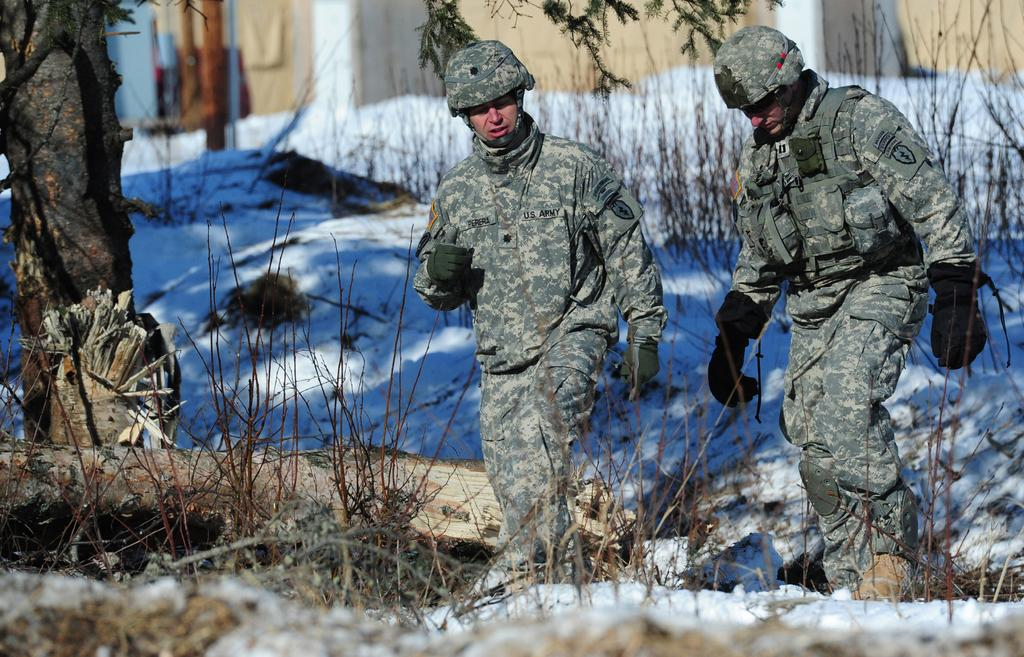How many people are wearing uniforms in the image? There are two people wearing uniforms in the image. What is located at the bottom of the image? There are plants at the bottom of the image. What can be seen in the background of the image? There is a tree and snow visible in the background of the image. What object is present in the image? There is a log in the image. What type of dog can be seen playing with the log in the image? There is no dog present in the image; it only features two people wearing uniforms, plants, a tree, snow, and a log. 